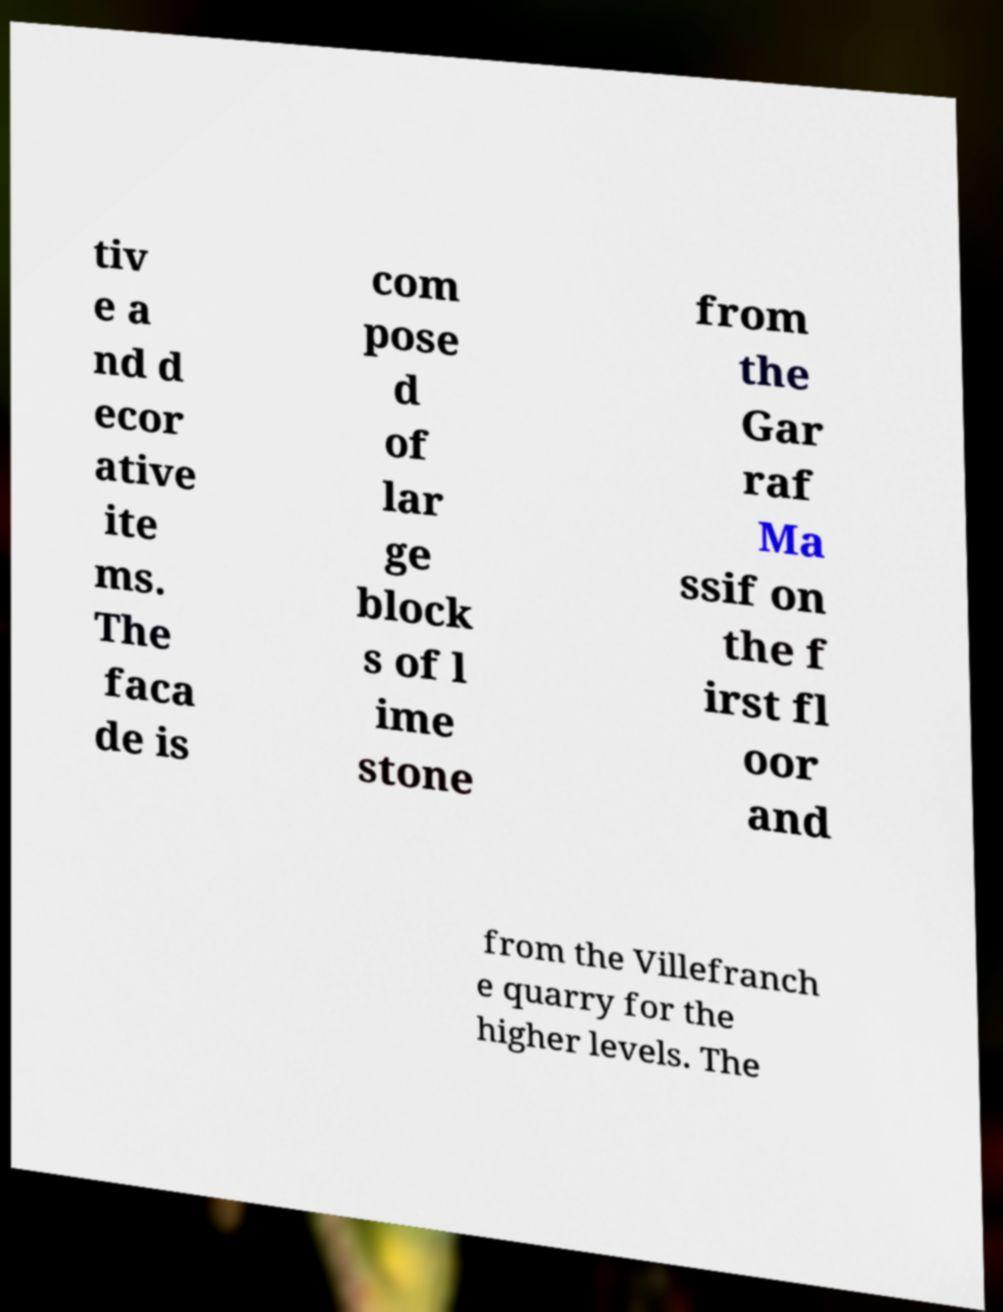I need the written content from this picture converted into text. Can you do that? tiv e a nd d ecor ative ite ms. The faca de is com pose d of lar ge block s of l ime stone from the Gar raf Ma ssif on the f irst fl oor and from the Villefranch e quarry for the higher levels. The 